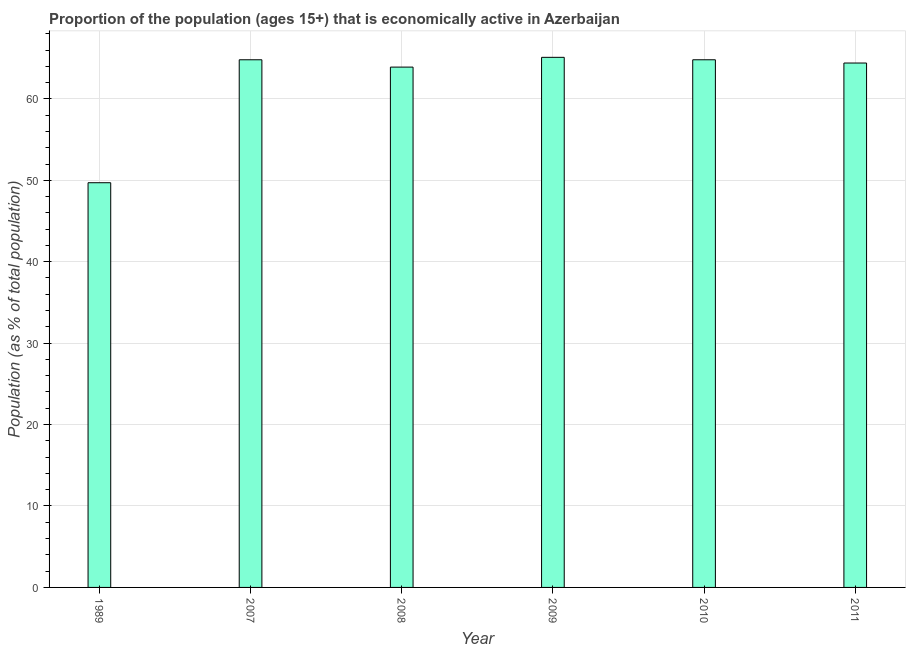Does the graph contain grids?
Make the answer very short. Yes. What is the title of the graph?
Offer a very short reply. Proportion of the population (ages 15+) that is economically active in Azerbaijan. What is the label or title of the X-axis?
Ensure brevity in your answer.  Year. What is the label or title of the Y-axis?
Keep it short and to the point. Population (as % of total population). What is the percentage of economically active population in 2007?
Offer a terse response. 64.8. Across all years, what is the maximum percentage of economically active population?
Keep it short and to the point. 65.1. Across all years, what is the minimum percentage of economically active population?
Ensure brevity in your answer.  49.7. In which year was the percentage of economically active population minimum?
Give a very brief answer. 1989. What is the sum of the percentage of economically active population?
Offer a very short reply. 372.7. What is the difference between the percentage of economically active population in 2008 and 2010?
Your answer should be compact. -0.9. What is the average percentage of economically active population per year?
Offer a very short reply. 62.12. What is the median percentage of economically active population?
Ensure brevity in your answer.  64.6. What is the ratio of the percentage of economically active population in 2009 to that in 2011?
Offer a very short reply. 1.01. Is the difference between the percentage of economically active population in 1989 and 2008 greater than the difference between any two years?
Offer a terse response. No. Is the sum of the percentage of economically active population in 2009 and 2010 greater than the maximum percentage of economically active population across all years?
Offer a terse response. Yes. What is the difference between the highest and the lowest percentage of economically active population?
Make the answer very short. 15.4. In how many years, is the percentage of economically active population greater than the average percentage of economically active population taken over all years?
Offer a terse response. 5. How many bars are there?
Ensure brevity in your answer.  6. How many years are there in the graph?
Keep it short and to the point. 6. What is the difference between two consecutive major ticks on the Y-axis?
Keep it short and to the point. 10. What is the Population (as % of total population) in 1989?
Make the answer very short. 49.7. What is the Population (as % of total population) in 2007?
Offer a terse response. 64.8. What is the Population (as % of total population) in 2008?
Give a very brief answer. 63.9. What is the Population (as % of total population) of 2009?
Ensure brevity in your answer.  65.1. What is the Population (as % of total population) of 2010?
Your answer should be compact. 64.8. What is the Population (as % of total population) in 2011?
Provide a short and direct response. 64.4. What is the difference between the Population (as % of total population) in 1989 and 2007?
Offer a very short reply. -15.1. What is the difference between the Population (as % of total population) in 1989 and 2008?
Keep it short and to the point. -14.2. What is the difference between the Population (as % of total population) in 1989 and 2009?
Your response must be concise. -15.4. What is the difference between the Population (as % of total population) in 1989 and 2010?
Provide a short and direct response. -15.1. What is the difference between the Population (as % of total population) in 1989 and 2011?
Make the answer very short. -14.7. What is the difference between the Population (as % of total population) in 2007 and 2008?
Keep it short and to the point. 0.9. What is the difference between the Population (as % of total population) in 2007 and 2010?
Provide a succinct answer. 0. What is the difference between the Population (as % of total population) in 2008 and 2010?
Provide a short and direct response. -0.9. What is the difference between the Population (as % of total population) in 2008 and 2011?
Provide a short and direct response. -0.5. What is the difference between the Population (as % of total population) in 2009 and 2010?
Give a very brief answer. 0.3. What is the difference between the Population (as % of total population) in 2009 and 2011?
Your response must be concise. 0.7. What is the difference between the Population (as % of total population) in 2010 and 2011?
Make the answer very short. 0.4. What is the ratio of the Population (as % of total population) in 1989 to that in 2007?
Make the answer very short. 0.77. What is the ratio of the Population (as % of total population) in 1989 to that in 2008?
Offer a terse response. 0.78. What is the ratio of the Population (as % of total population) in 1989 to that in 2009?
Make the answer very short. 0.76. What is the ratio of the Population (as % of total population) in 1989 to that in 2010?
Give a very brief answer. 0.77. What is the ratio of the Population (as % of total population) in 1989 to that in 2011?
Offer a very short reply. 0.77. What is the ratio of the Population (as % of total population) in 2007 to that in 2008?
Make the answer very short. 1.01. What is the ratio of the Population (as % of total population) in 2007 to that in 2009?
Offer a very short reply. 0.99. What is the ratio of the Population (as % of total population) in 2007 to that in 2010?
Your response must be concise. 1. What is the ratio of the Population (as % of total population) in 2007 to that in 2011?
Provide a succinct answer. 1.01. What is the ratio of the Population (as % of total population) in 2009 to that in 2010?
Offer a terse response. 1. What is the ratio of the Population (as % of total population) in 2009 to that in 2011?
Provide a succinct answer. 1.01. What is the ratio of the Population (as % of total population) in 2010 to that in 2011?
Ensure brevity in your answer.  1.01. 